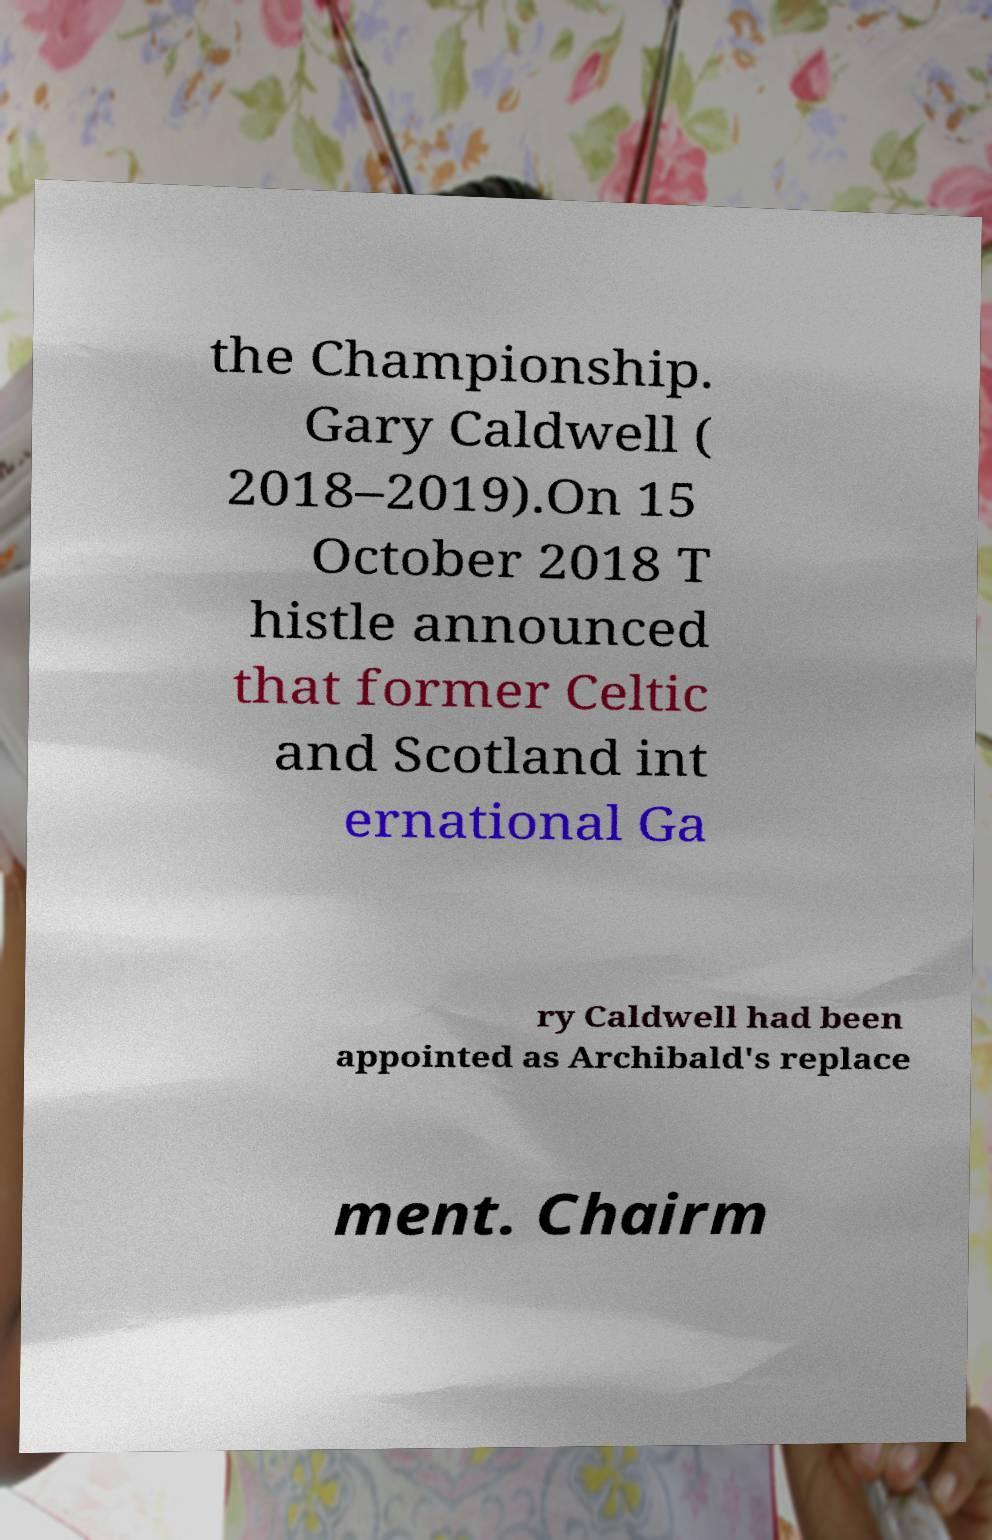For documentation purposes, I need the text within this image transcribed. Could you provide that? the Championship. Gary Caldwell ( 2018–2019).On 15 October 2018 T histle announced that former Celtic and Scotland int ernational Ga ry Caldwell had been appointed as Archibald's replace ment. Chairm 